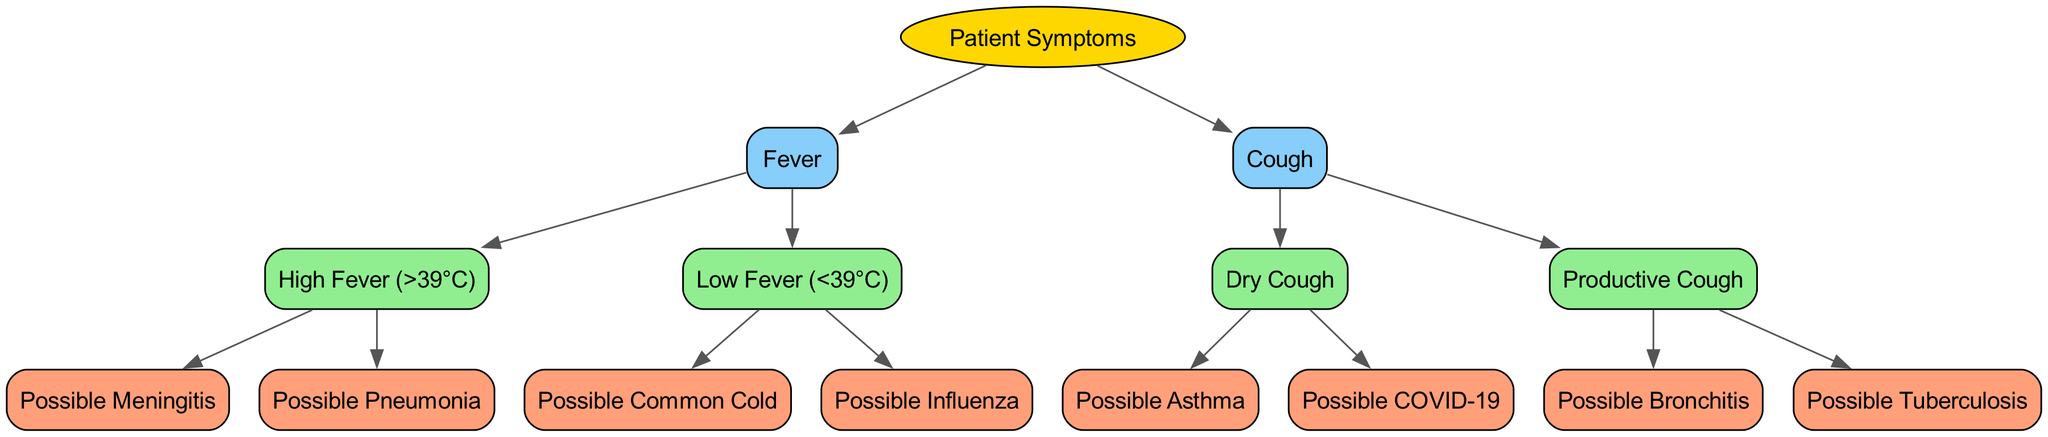What is the root of the decision tree? The root node of the decision tree is "Patient Symptoms." This can be identified as the starting point from which all other nodes branch out.
Answer: Patient Symptoms How many primary symptom nodes are there? There are two primary symptom nodes in the diagram: "Fever" and "Cough." These are directly connected to the root node.
Answer: 2 Which condition is indicated by a high fever? A high fever leads to two possible conditions: "Possible Meningitis" and "Possible Pneumonia." These are the outcomes when the high fever node is followed.
Answer: Possible Meningitis, Possible Pneumonia What type of cough suggests possible asthma? The type of cough that suggests possible asthma is a "Dry Cough." It is the first outcome when navigating from the "Cough" node through "Dry Cough."
Answer: Dry Cough If a patient has a productive cough, what are the possible conditions? A productive cough leads to two potential conditions: "Possible Bronchitis" and "Possible Tuberculosis." Following the "Productive Cough" node directly shows these outcomes.
Answer: Possible Bronchitis, Possible Tuberculosis What is the connection between low fever and common cold? The "Low Fever (<39°C)" node has a direct child node labeled "Possible Common Cold," indicating that a low fever could be associated with this condition.
Answer: Possible Common Cold Which symptom node has more child nodes? The symptom node "Cough" has more child nodes than "Fever." "Cough" branches into "Dry Cough" and "Productive Cough," while "Fever" splits into "High Fever" and "Low Fever."
Answer: Cough How many potential conditions are described for dry cough? There are two potential conditions listed for dry cough: "Possible Asthma" and "Possible COVID-19." These are the final outcomes of the decision path taken from dry cough.
Answer: 2 What color represents leaf nodes in the diagram? Leaf nodes, which represent potential conditions without further branching, are colored light salmon in the diagram, indicating they are final outcomes in the decision-making process.
Answer: Light salmon 